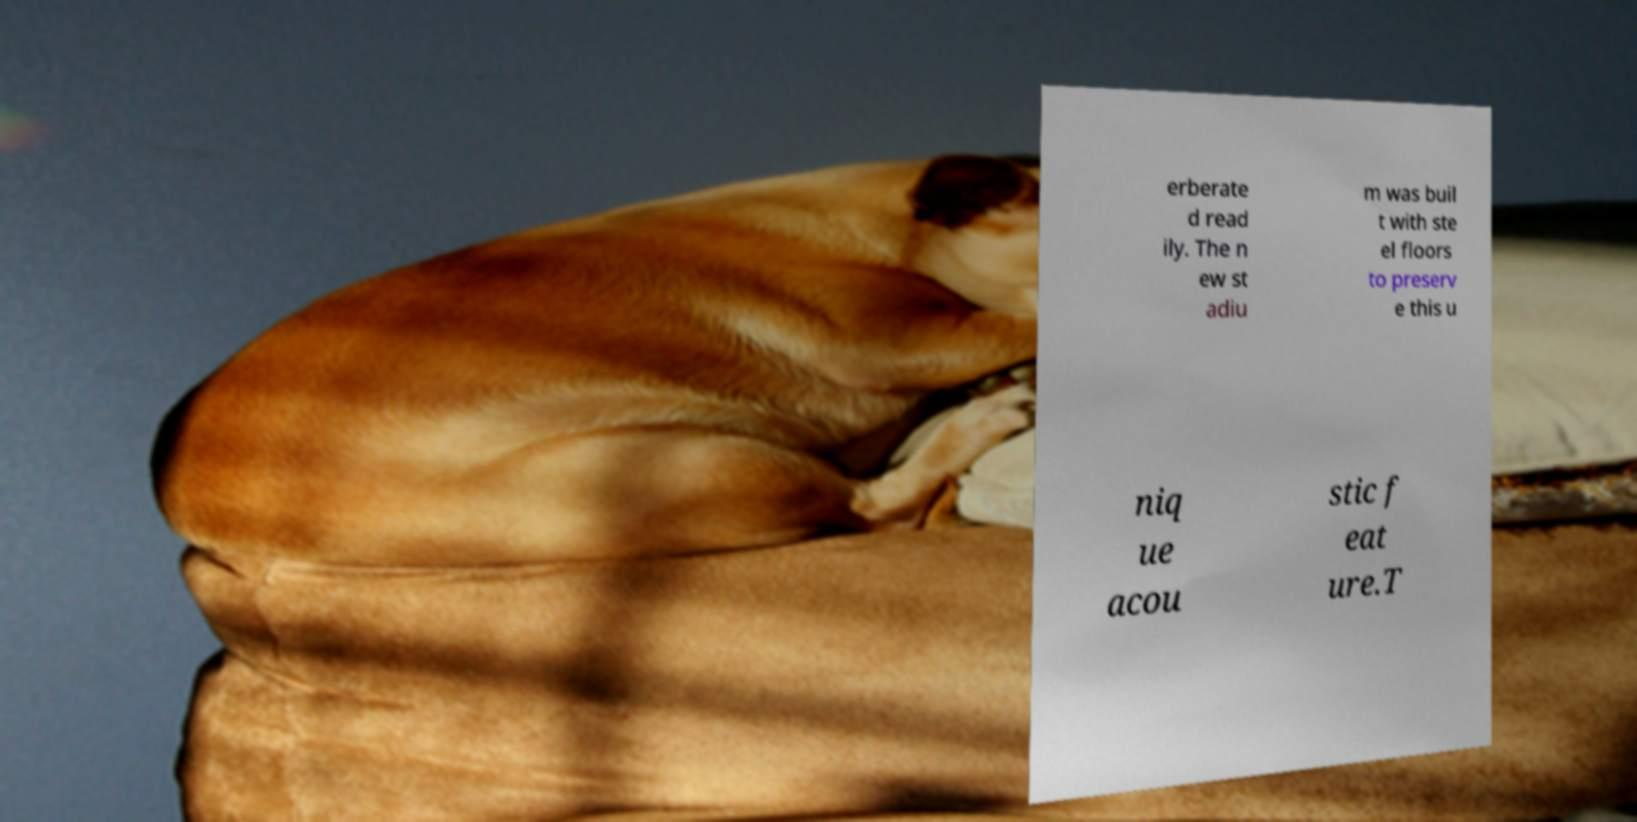Please identify and transcribe the text found in this image. erberate d read ily. The n ew st adiu m was buil t with ste el floors to preserv e this u niq ue acou stic f eat ure.T 